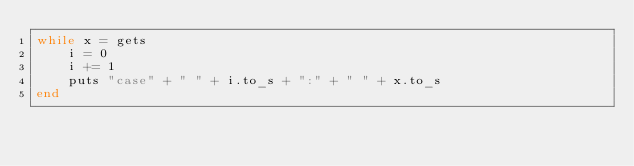<code> <loc_0><loc_0><loc_500><loc_500><_Ruby_>while x = gets
    i = 0
    i += 1
    puts "case" + " " + i.to_s + ":" + " " + x.to_s
end

</code> 